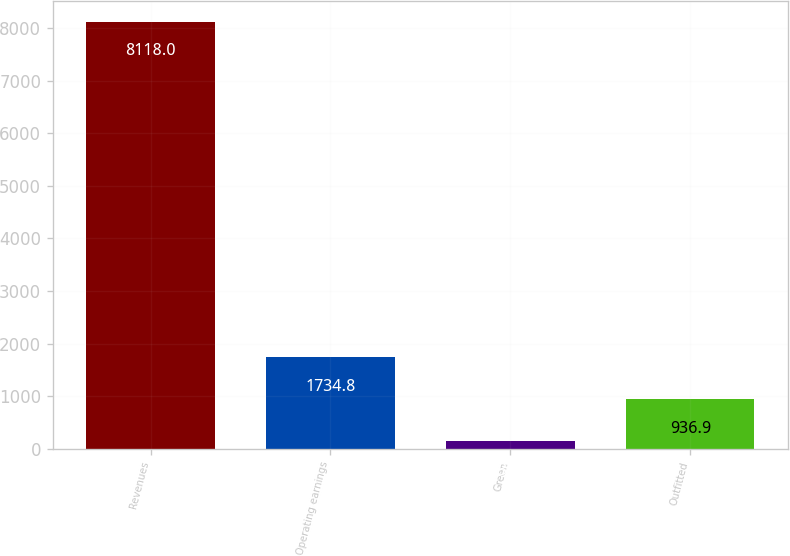Convert chart. <chart><loc_0><loc_0><loc_500><loc_500><bar_chart><fcel>Revenues<fcel>Operating earnings<fcel>Green<fcel>Outfitted<nl><fcel>8118<fcel>1734.8<fcel>139<fcel>936.9<nl></chart> 